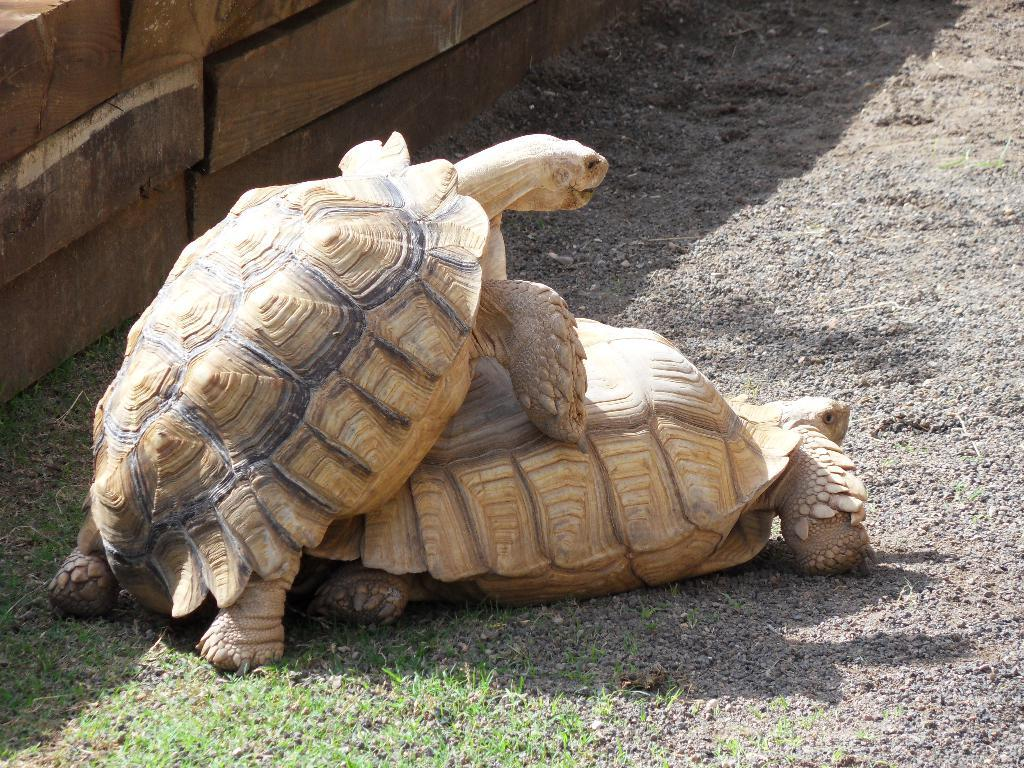What is the main subject in the center of the image? There is a tortoise in the center of the image. Can you describe the position of the second tortoise in the image? There is another tortoise above the first one. What type of material can be seen in the top left side of the image? There are wooden boards in the top left side of the image. How does the sponge help the tortoise in the image? There is no sponge present in the image, so it cannot help the tortoise. 